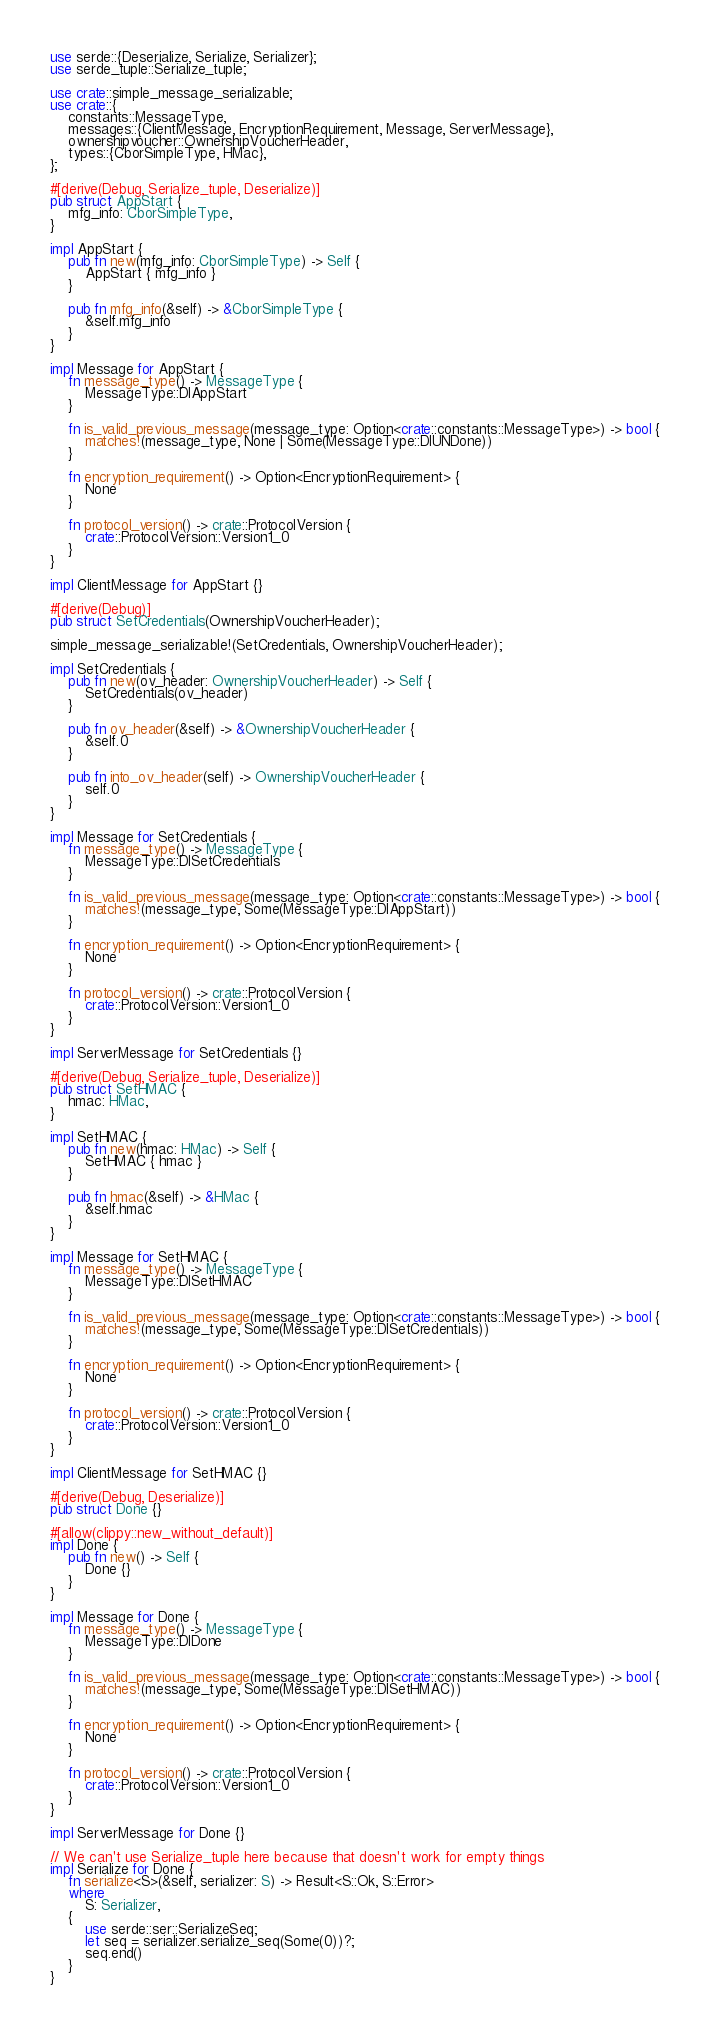Convert code to text. <code><loc_0><loc_0><loc_500><loc_500><_Rust_>use serde::{Deserialize, Serialize, Serializer};
use serde_tuple::Serialize_tuple;

use crate::simple_message_serializable;
use crate::{
    constants::MessageType,
    messages::{ClientMessage, EncryptionRequirement, Message, ServerMessage},
    ownershipvoucher::OwnershipVoucherHeader,
    types::{CborSimpleType, HMac},
};

#[derive(Debug, Serialize_tuple, Deserialize)]
pub struct AppStart {
    mfg_info: CborSimpleType,
}

impl AppStart {
    pub fn new(mfg_info: CborSimpleType) -> Self {
        AppStart { mfg_info }
    }

    pub fn mfg_info(&self) -> &CborSimpleType {
        &self.mfg_info
    }
}

impl Message for AppStart {
    fn message_type() -> MessageType {
        MessageType::DIAppStart
    }

    fn is_valid_previous_message(message_type: Option<crate::constants::MessageType>) -> bool {
        matches!(message_type, None | Some(MessageType::DIUNDone))
    }

    fn encryption_requirement() -> Option<EncryptionRequirement> {
        None
    }

    fn protocol_version() -> crate::ProtocolVersion {
        crate::ProtocolVersion::Version1_0
    }
}

impl ClientMessage for AppStart {}

#[derive(Debug)]
pub struct SetCredentials(OwnershipVoucherHeader);

simple_message_serializable!(SetCredentials, OwnershipVoucherHeader);

impl SetCredentials {
    pub fn new(ov_header: OwnershipVoucherHeader) -> Self {
        SetCredentials(ov_header)
    }

    pub fn ov_header(&self) -> &OwnershipVoucherHeader {
        &self.0
    }

    pub fn into_ov_header(self) -> OwnershipVoucherHeader {
        self.0
    }
}

impl Message for SetCredentials {
    fn message_type() -> MessageType {
        MessageType::DISetCredentials
    }

    fn is_valid_previous_message(message_type: Option<crate::constants::MessageType>) -> bool {
        matches!(message_type, Some(MessageType::DIAppStart))
    }

    fn encryption_requirement() -> Option<EncryptionRequirement> {
        None
    }

    fn protocol_version() -> crate::ProtocolVersion {
        crate::ProtocolVersion::Version1_0
    }
}

impl ServerMessage for SetCredentials {}

#[derive(Debug, Serialize_tuple, Deserialize)]
pub struct SetHMAC {
    hmac: HMac,
}

impl SetHMAC {
    pub fn new(hmac: HMac) -> Self {
        SetHMAC { hmac }
    }

    pub fn hmac(&self) -> &HMac {
        &self.hmac
    }
}

impl Message for SetHMAC {
    fn message_type() -> MessageType {
        MessageType::DISetHMAC
    }

    fn is_valid_previous_message(message_type: Option<crate::constants::MessageType>) -> bool {
        matches!(message_type, Some(MessageType::DISetCredentials))
    }

    fn encryption_requirement() -> Option<EncryptionRequirement> {
        None
    }

    fn protocol_version() -> crate::ProtocolVersion {
        crate::ProtocolVersion::Version1_0
    }
}

impl ClientMessage for SetHMAC {}

#[derive(Debug, Deserialize)]
pub struct Done {}

#[allow(clippy::new_without_default)]
impl Done {
    pub fn new() -> Self {
        Done {}
    }
}

impl Message for Done {
    fn message_type() -> MessageType {
        MessageType::DIDone
    }

    fn is_valid_previous_message(message_type: Option<crate::constants::MessageType>) -> bool {
        matches!(message_type, Some(MessageType::DISetHMAC))
    }

    fn encryption_requirement() -> Option<EncryptionRequirement> {
        None
    }

    fn protocol_version() -> crate::ProtocolVersion {
        crate::ProtocolVersion::Version1_0
    }
}

impl ServerMessage for Done {}

// We can't use Serialize_tuple here because that doesn't work for empty things
impl Serialize for Done {
    fn serialize<S>(&self, serializer: S) -> Result<S::Ok, S::Error>
    where
        S: Serializer,
    {
        use serde::ser::SerializeSeq;
        let seq = serializer.serialize_seq(Some(0))?;
        seq.end()
    }
}
</code> 